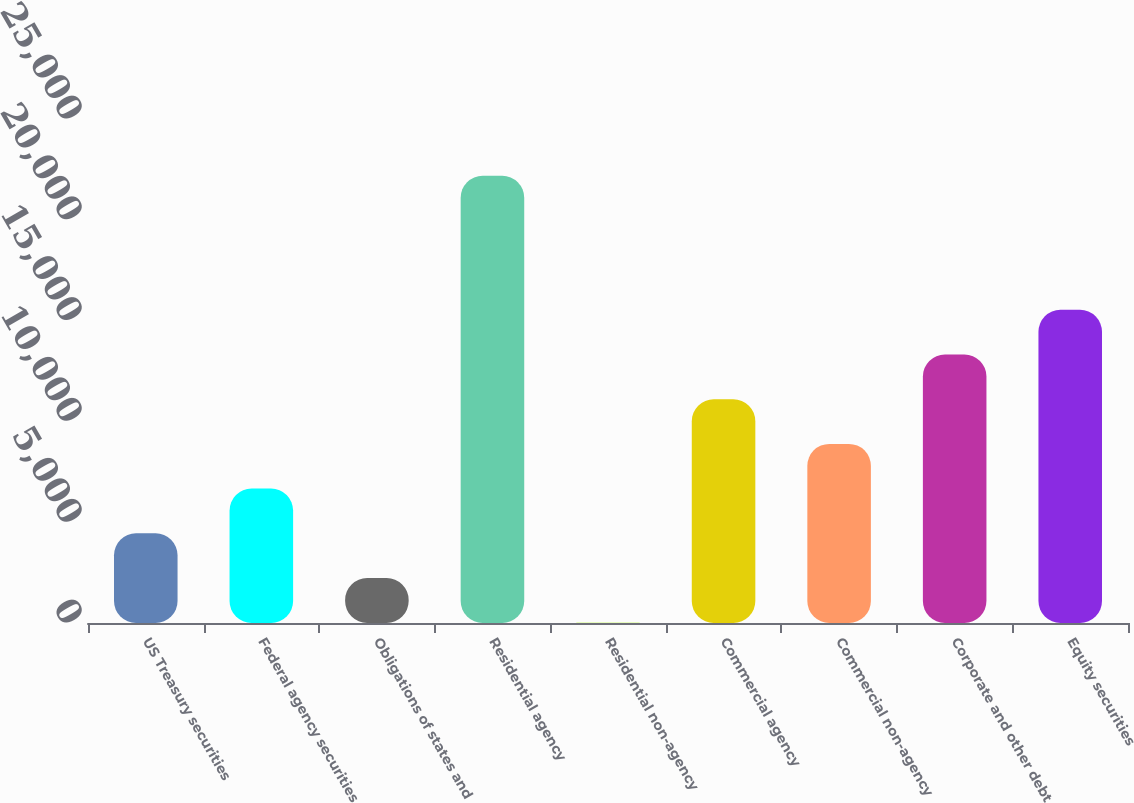<chart> <loc_0><loc_0><loc_500><loc_500><bar_chart><fcel>US Treasury securities<fcel>Federal agency securities<fcel>Obligations of states and<fcel>Residential agency<fcel>Residential non-agency<fcel>Commercial agency<fcel>Commercial non-agency<fcel>Corporate and other debt<fcel>Equity securities<nl><fcel>4449.6<fcel>6666.4<fcel>2232.8<fcel>22184<fcel>16<fcel>11100<fcel>8883.2<fcel>13316.8<fcel>15533.6<nl></chart> 